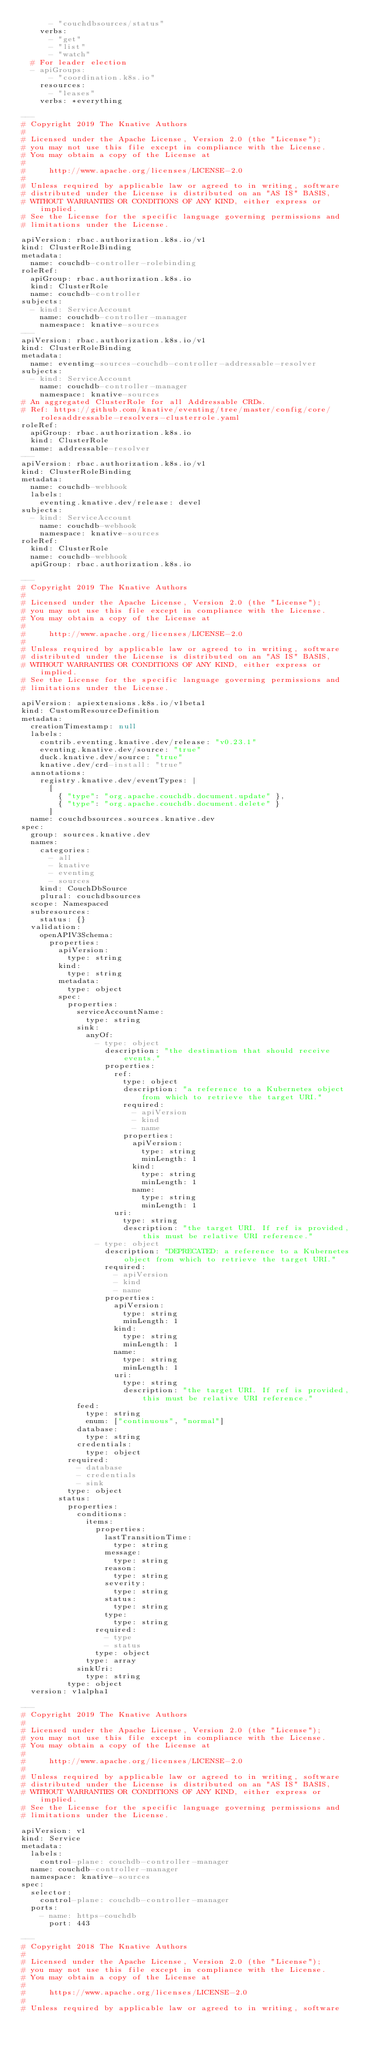<code> <loc_0><loc_0><loc_500><loc_500><_YAML_>      - "couchdbsources/status"
    verbs:
      - "get"
      - "list"
      - "watch"
  # For leader election
  - apiGroups:
      - "coordination.k8s.io"
    resources:
      - "leases"
    verbs: *everything

---
# Copyright 2019 The Knative Authors
#
# Licensed under the Apache License, Version 2.0 (the "License");
# you may not use this file except in compliance with the License.
# You may obtain a copy of the License at
#
#     http://www.apache.org/licenses/LICENSE-2.0
#
# Unless required by applicable law or agreed to in writing, software
# distributed under the License is distributed on an "AS IS" BASIS,
# WITHOUT WARRANTIES OR CONDITIONS OF ANY KIND, either express or implied.
# See the License for the specific language governing permissions and
# limitations under the License.

apiVersion: rbac.authorization.k8s.io/v1
kind: ClusterRoleBinding
metadata:
  name: couchdb-controller-rolebinding
roleRef:
  apiGroup: rbac.authorization.k8s.io
  kind: ClusterRole
  name: couchdb-controller
subjects:
  - kind: ServiceAccount
    name: couchdb-controller-manager
    namespace: knative-sources
---
apiVersion: rbac.authorization.k8s.io/v1
kind: ClusterRoleBinding
metadata:
  name: eventing-sources-couchdb-controller-addressable-resolver
subjects:
  - kind: ServiceAccount
    name: couchdb-controller-manager
    namespace: knative-sources
# An aggregated ClusterRole for all Addressable CRDs.
# Ref: https://github.com/knative/eventing/tree/master/config/core/rolesaddressable-resolvers-clusterrole.yaml
roleRef:
  apiGroup: rbac.authorization.k8s.io
  kind: ClusterRole
  name: addressable-resolver
---
apiVersion: rbac.authorization.k8s.io/v1
kind: ClusterRoleBinding
metadata:
  name: couchdb-webhook
  labels:
    eventing.knative.dev/release: devel
subjects:
  - kind: ServiceAccount
    name: couchdb-webhook
    namespace: knative-sources
roleRef:
  kind: ClusterRole
  name: couchdb-webhook
  apiGroup: rbac.authorization.k8s.io

---
# Copyright 2019 The Knative Authors
#
# Licensed under the Apache License, Version 2.0 (the "License");
# you may not use this file except in compliance with the License.
# You may obtain a copy of the License at
#
#     http://www.apache.org/licenses/LICENSE-2.0
#
# Unless required by applicable law or agreed to in writing, software
# distributed under the License is distributed on an "AS IS" BASIS,
# WITHOUT WARRANTIES OR CONDITIONS OF ANY KIND, either express or implied.
# See the License for the specific language governing permissions and
# limitations under the License.

apiVersion: apiextensions.k8s.io/v1beta1
kind: CustomResourceDefinition
metadata:
  creationTimestamp: null
  labels:
    contrib.eventing.knative.dev/release: "v0.23.1"
    eventing.knative.dev/source: "true"
    duck.knative.dev/source: "true"
    knative.dev/crd-install: "true"
  annotations:
    registry.knative.dev/eventTypes: |
      [
        { "type": "org.apache.couchdb.document.update" },
        { "type": "org.apache.couchdb.document.delete" }
      ]
  name: couchdbsources.sources.knative.dev
spec:
  group: sources.knative.dev
  names:
    categories:
      - all
      - knative
      - eventing
      - sources
    kind: CouchDbSource
    plural: couchdbsources
  scope: Namespaced
  subresources:
    status: {}
  validation:
    openAPIV3Schema:
      properties:
        apiVersion:
          type: string
        kind:
          type: string
        metadata:
          type: object
        spec:
          properties:
            serviceAccountName:
              type: string
            sink:
              anyOf:
                - type: object
                  description: "the destination that should receive events."
                  properties:
                    ref:
                      type: object
                      description: "a reference to a Kubernetes object from which to retrieve the target URI."
                      required:
                        - apiVersion
                        - kind
                        - name
                      properties:
                        apiVersion:
                          type: string
                          minLength: 1
                        kind:
                          type: string
                          minLength: 1
                        name:
                          type: string
                          minLength: 1
                    uri:
                      type: string
                      description: "the target URI. If ref is provided, this must be relative URI reference."
                - type: object
                  description: "DEPRECATED: a reference to a Kubernetes object from which to retrieve the target URI."
                  required:
                    - apiVersion
                    - kind
                    - name
                  properties:
                    apiVersion:
                      type: string
                      minLength: 1
                    kind:
                      type: string
                      minLength: 1
                    name:
                      type: string
                      minLength: 1
                    uri:
                      type: string
                      description: "the target URI. If ref is provided, this must be relative URI reference."
            feed:
              type: string
              enum: ["continuous", "normal"]
            database:
              type: string
            credentials:
              type: object
          required:
            - database
            - credentials
            - sink
          type: object
        status:
          properties:
            conditions:
              items:
                properties:
                  lastTransitionTime:
                    type: string
                  message:
                    type: string
                  reason:
                    type: string
                  severity:
                    type: string
                  status:
                    type: string
                  type:
                    type: string
                required:
                  - type
                  - status
                type: object
              type: array
            sinkUri:
              type: string
          type: object
  version: v1alpha1

---
# Copyright 2019 The Knative Authors
#
# Licensed under the Apache License, Version 2.0 (the "License");
# you may not use this file except in compliance with the License.
# You may obtain a copy of the License at
#
#     http://www.apache.org/licenses/LICENSE-2.0
#
# Unless required by applicable law or agreed to in writing, software
# distributed under the License is distributed on an "AS IS" BASIS,
# WITHOUT WARRANTIES OR CONDITIONS OF ANY KIND, either express or implied.
# See the License for the specific language governing permissions and
# limitations under the License.

apiVersion: v1
kind: Service
metadata:
  labels:
    control-plane: couchdb-controller-manager
  name: couchdb-controller-manager
  namespace: knative-sources
spec:
  selector:
    control-plane: couchdb-controller-manager
  ports:
    - name: https-couchdb
      port: 443

---
# Copyright 2018 The Knative Authors
#
# Licensed under the Apache License, Version 2.0 (the "License");
# you may not use this file except in compliance with the License.
# You may obtain a copy of the License at
#
#     https://www.apache.org/licenses/LICENSE-2.0
#
# Unless required by applicable law or agreed to in writing, software</code> 